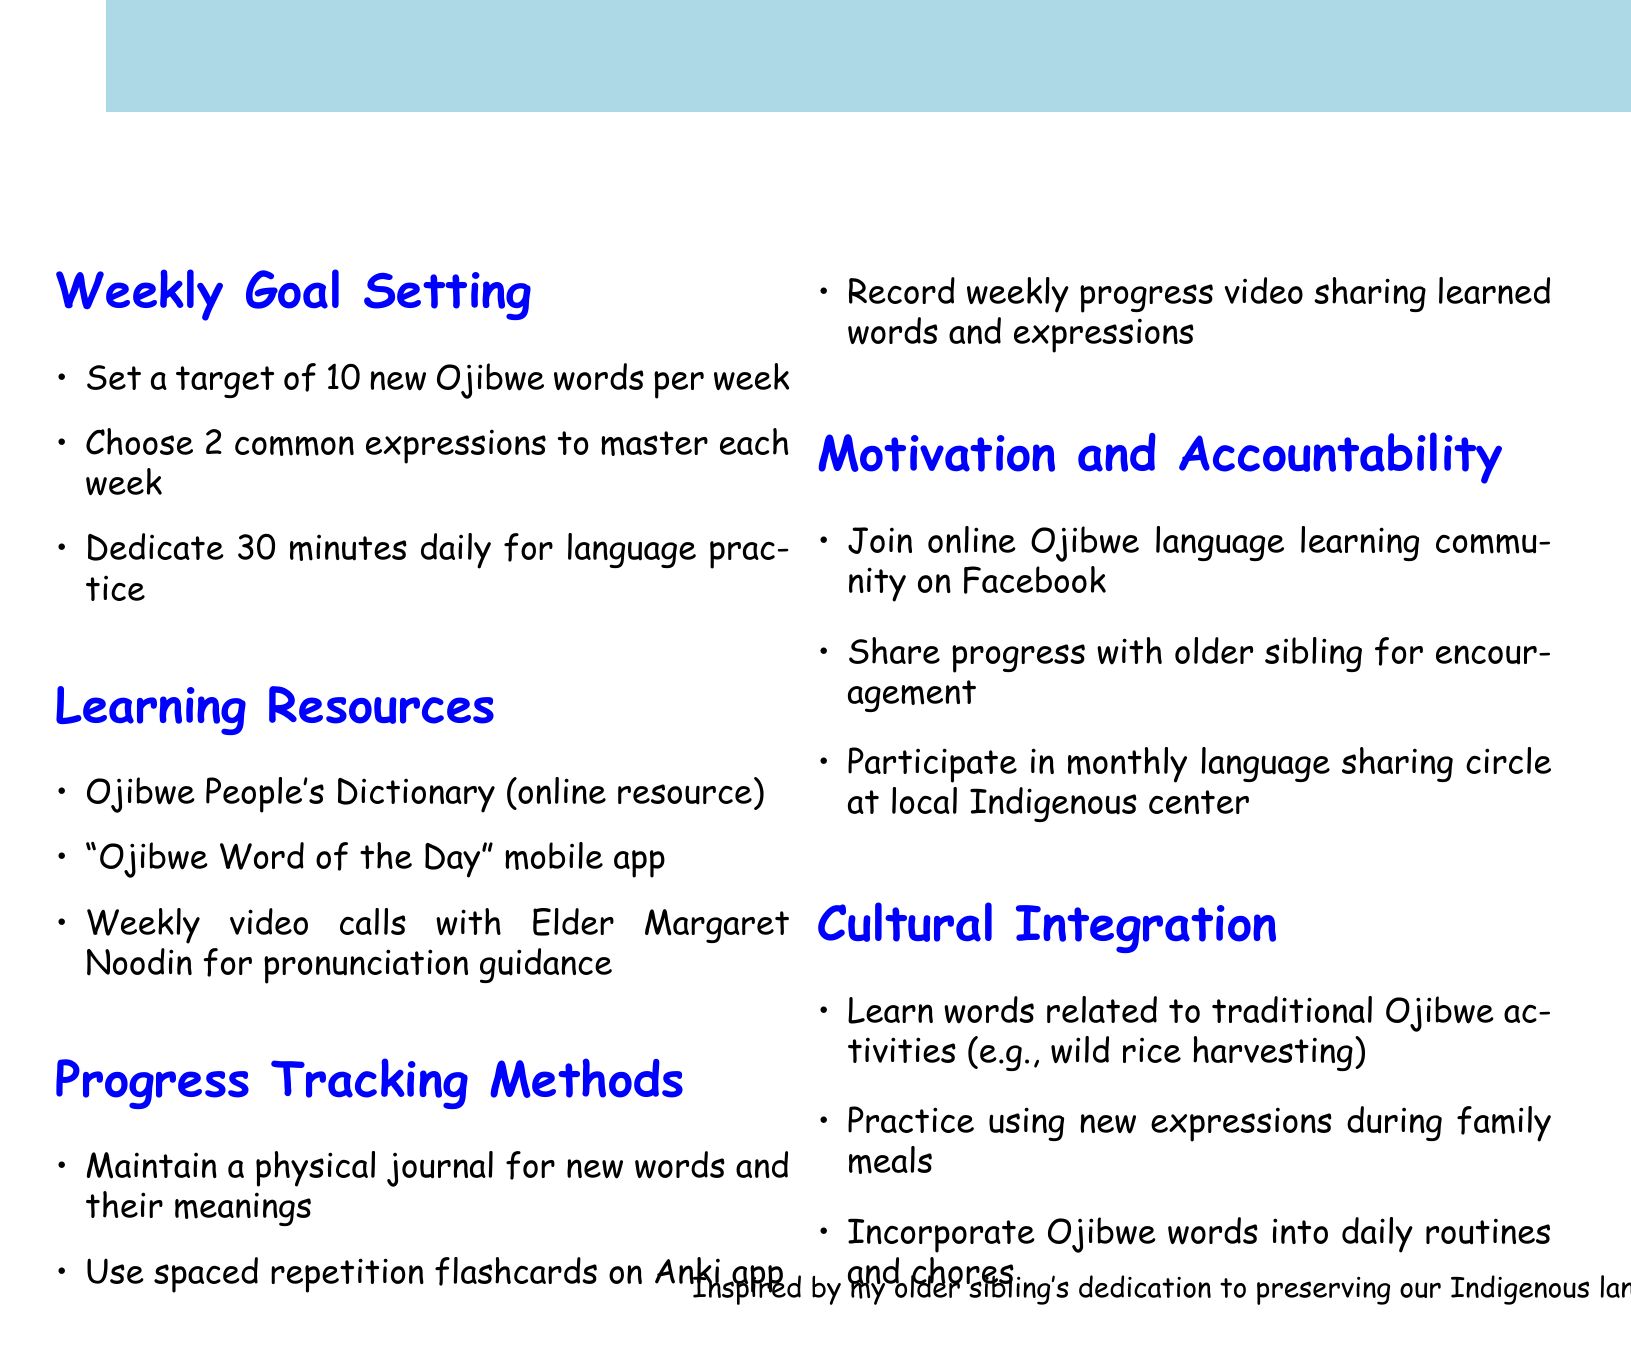What is the target number of new Ojibwe words per week? The document specifies a target for learning new Ojibwe words, which is stated clearly.
Answer: 10 Who provides pronunciation guidance during the weekly video calls? The document identifies the person who offers help with pronunciation in the learning resources section.
Answer: Elder Margaret Noodin What is one method suggested for tracking progress? The document outlines a few methods for keeping track of language learning, prompting a specific method for tracking progress.
Answer: Maintain a physical journal How many expressions should be chosen to master each week? The document indicates how many common expressions to focus on weekly and is specified in the goal-setting section.
Answer: 2 What is a suggested frequency of participation in the language sharing circle? This question looks for the interval at which participation is encouraged in the community aspects of learning the language.
Answer: monthly What is the daily time dedication suggested for language practice? The document notes a specific duration to be dedicated each day for language practice, helping to clarify the expected commitment.
Answer: 30 minutes Which app is recommended for spaced repetition flashcards? Identifying the specific app dedicated to flashcards is key for understanding the learning resources available.
Answer: Anki app What type of community is suggested to join for additional support? The document indicates a specific online community to foster engagement and support for language learning.
Answer: Ojibwe language learning community on Facebook 